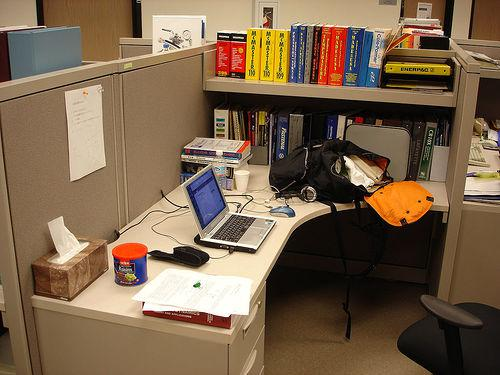Question: where are the books?
Choices:
A. In a pile on the coffee table.
B. Arranged in the shelf.
C. Stacked on the kitchen counter.
D. Placed in a storage box.
Answer with the letter. Answer: B Question: how is the laptop screen?
Choices:
A. It is flickering.
B. It is too bright.
C. It is too dark.
D. On.
Answer with the letter. Answer: D Question: what is the tissue paper box color?
Choices:
A. Brown.
B. Purple.
C. Blue.
D. Green.
Answer with the letter. Answer: A 